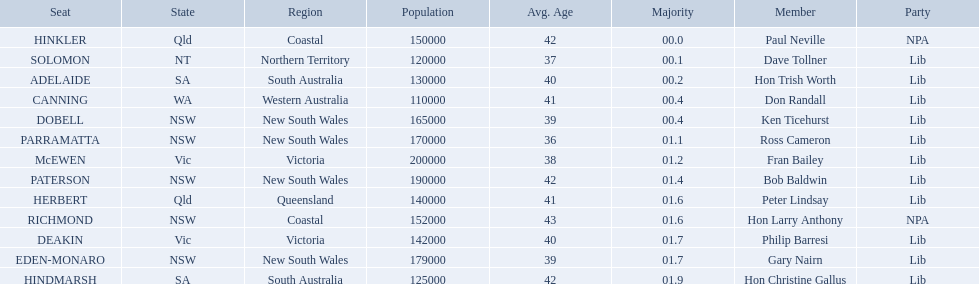Who are all the lib party members? Dave Tollner, Hon Trish Worth, Don Randall, Ken Ticehurst, Ross Cameron, Fran Bailey, Bob Baldwin, Peter Lindsay, Philip Barresi, Gary Nairn, Hon Christine Gallus. What lib party members are in sa? Hon Trish Worth, Hon Christine Gallus. What is the highest difference in majority between members in sa? 01.9. 